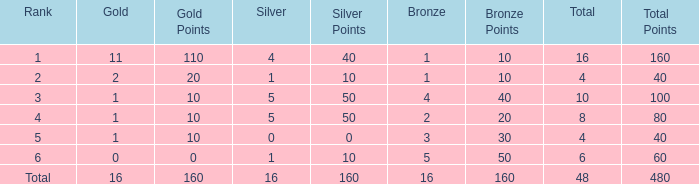What is the total gold that has bronze less than 2, a silver of 1 and total more than 4? None. 